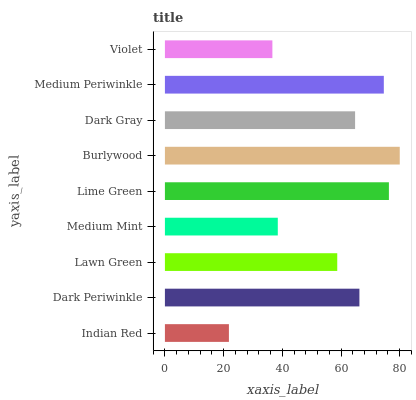Is Indian Red the minimum?
Answer yes or no. Yes. Is Burlywood the maximum?
Answer yes or no. Yes. Is Dark Periwinkle the minimum?
Answer yes or no. No. Is Dark Periwinkle the maximum?
Answer yes or no. No. Is Dark Periwinkle greater than Indian Red?
Answer yes or no. Yes. Is Indian Red less than Dark Periwinkle?
Answer yes or no. Yes. Is Indian Red greater than Dark Periwinkle?
Answer yes or no. No. Is Dark Periwinkle less than Indian Red?
Answer yes or no. No. Is Dark Gray the high median?
Answer yes or no. Yes. Is Dark Gray the low median?
Answer yes or no. Yes. Is Medium Periwinkle the high median?
Answer yes or no. No. Is Medium Mint the low median?
Answer yes or no. No. 